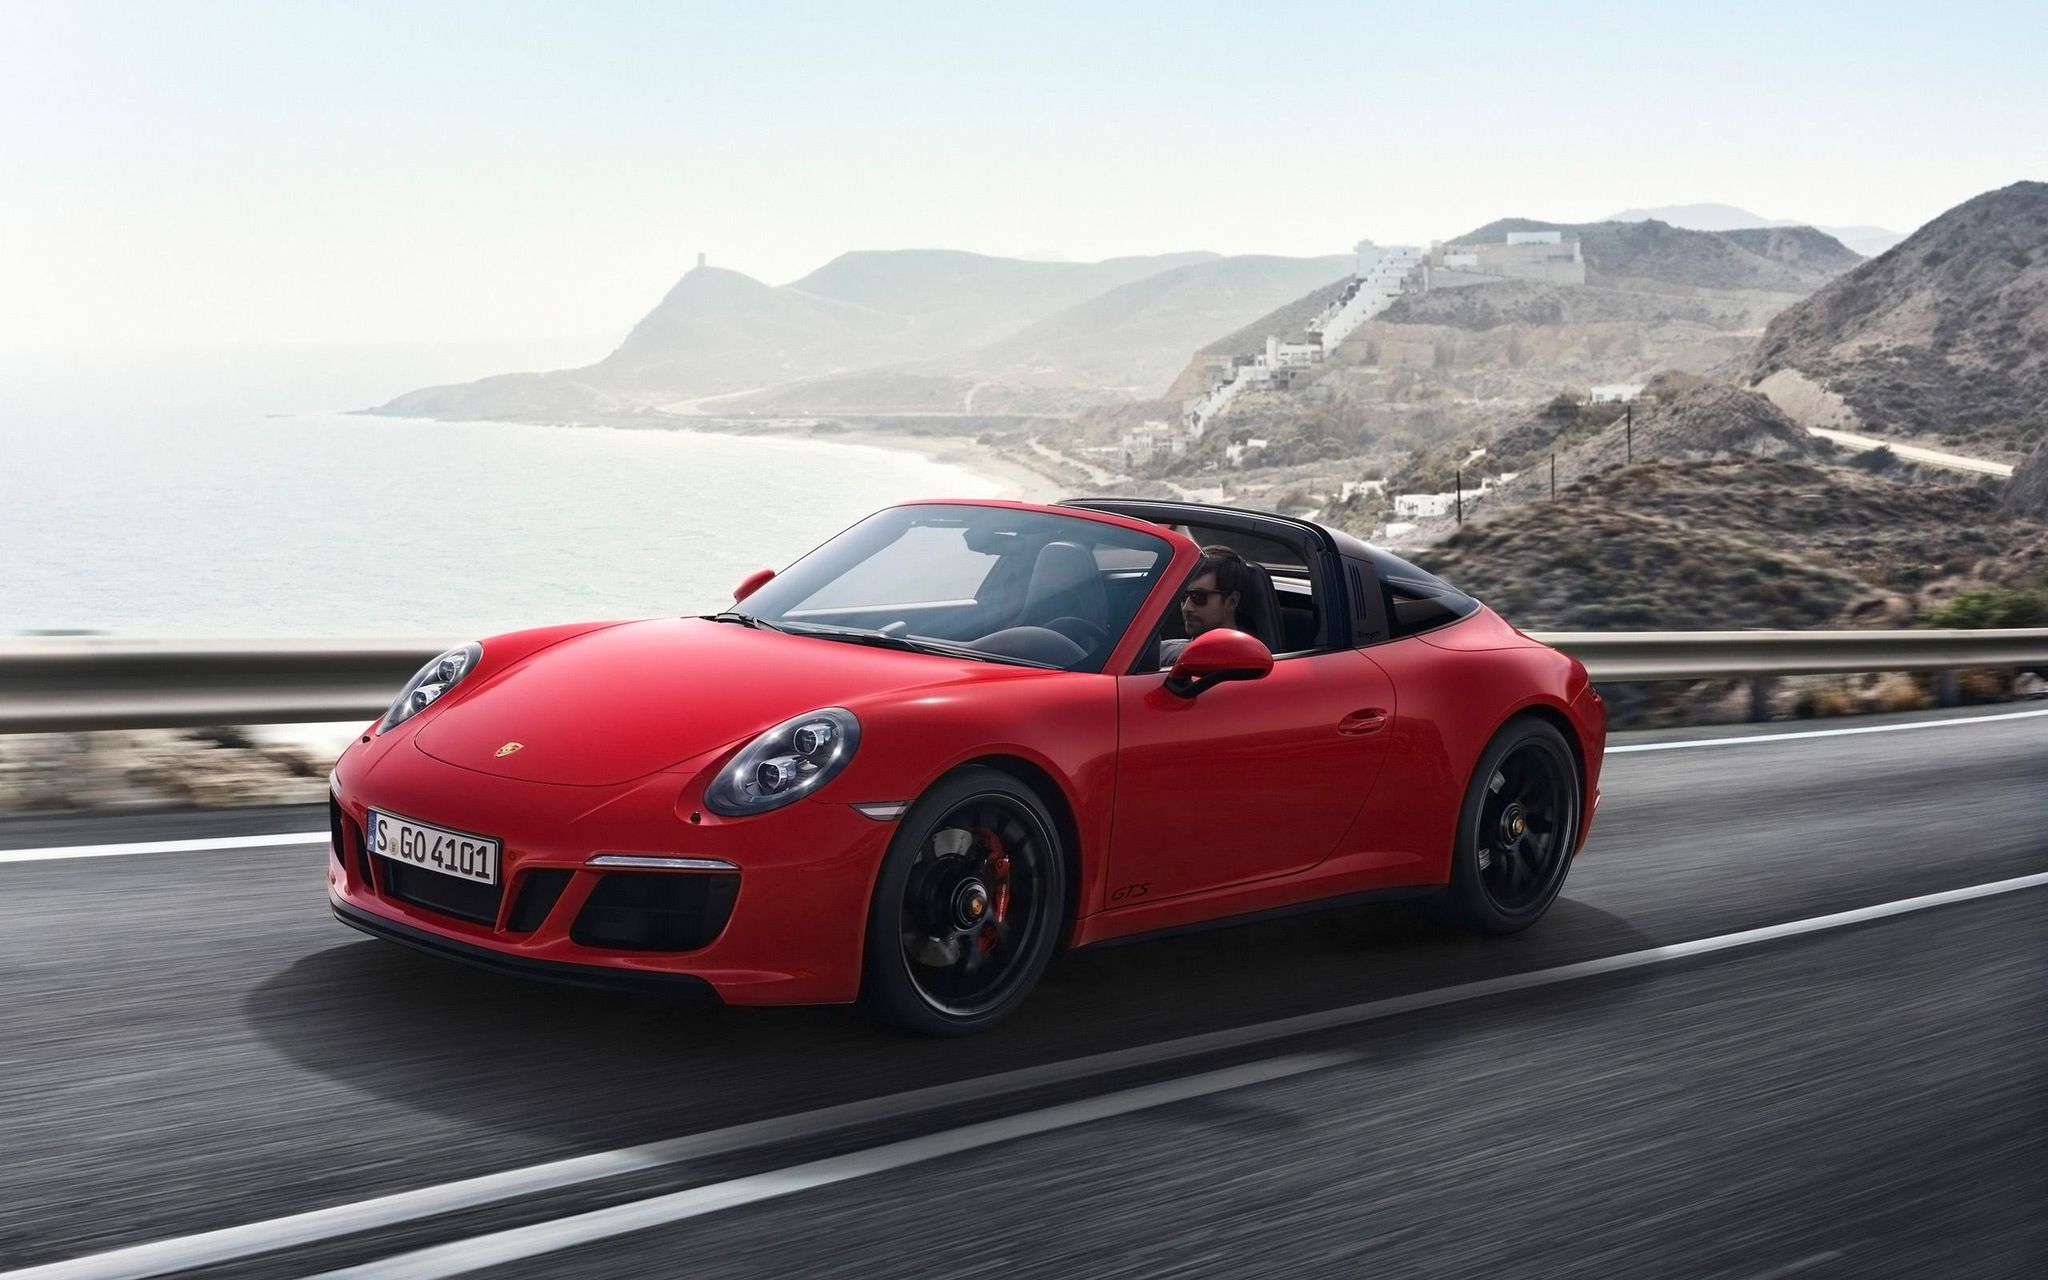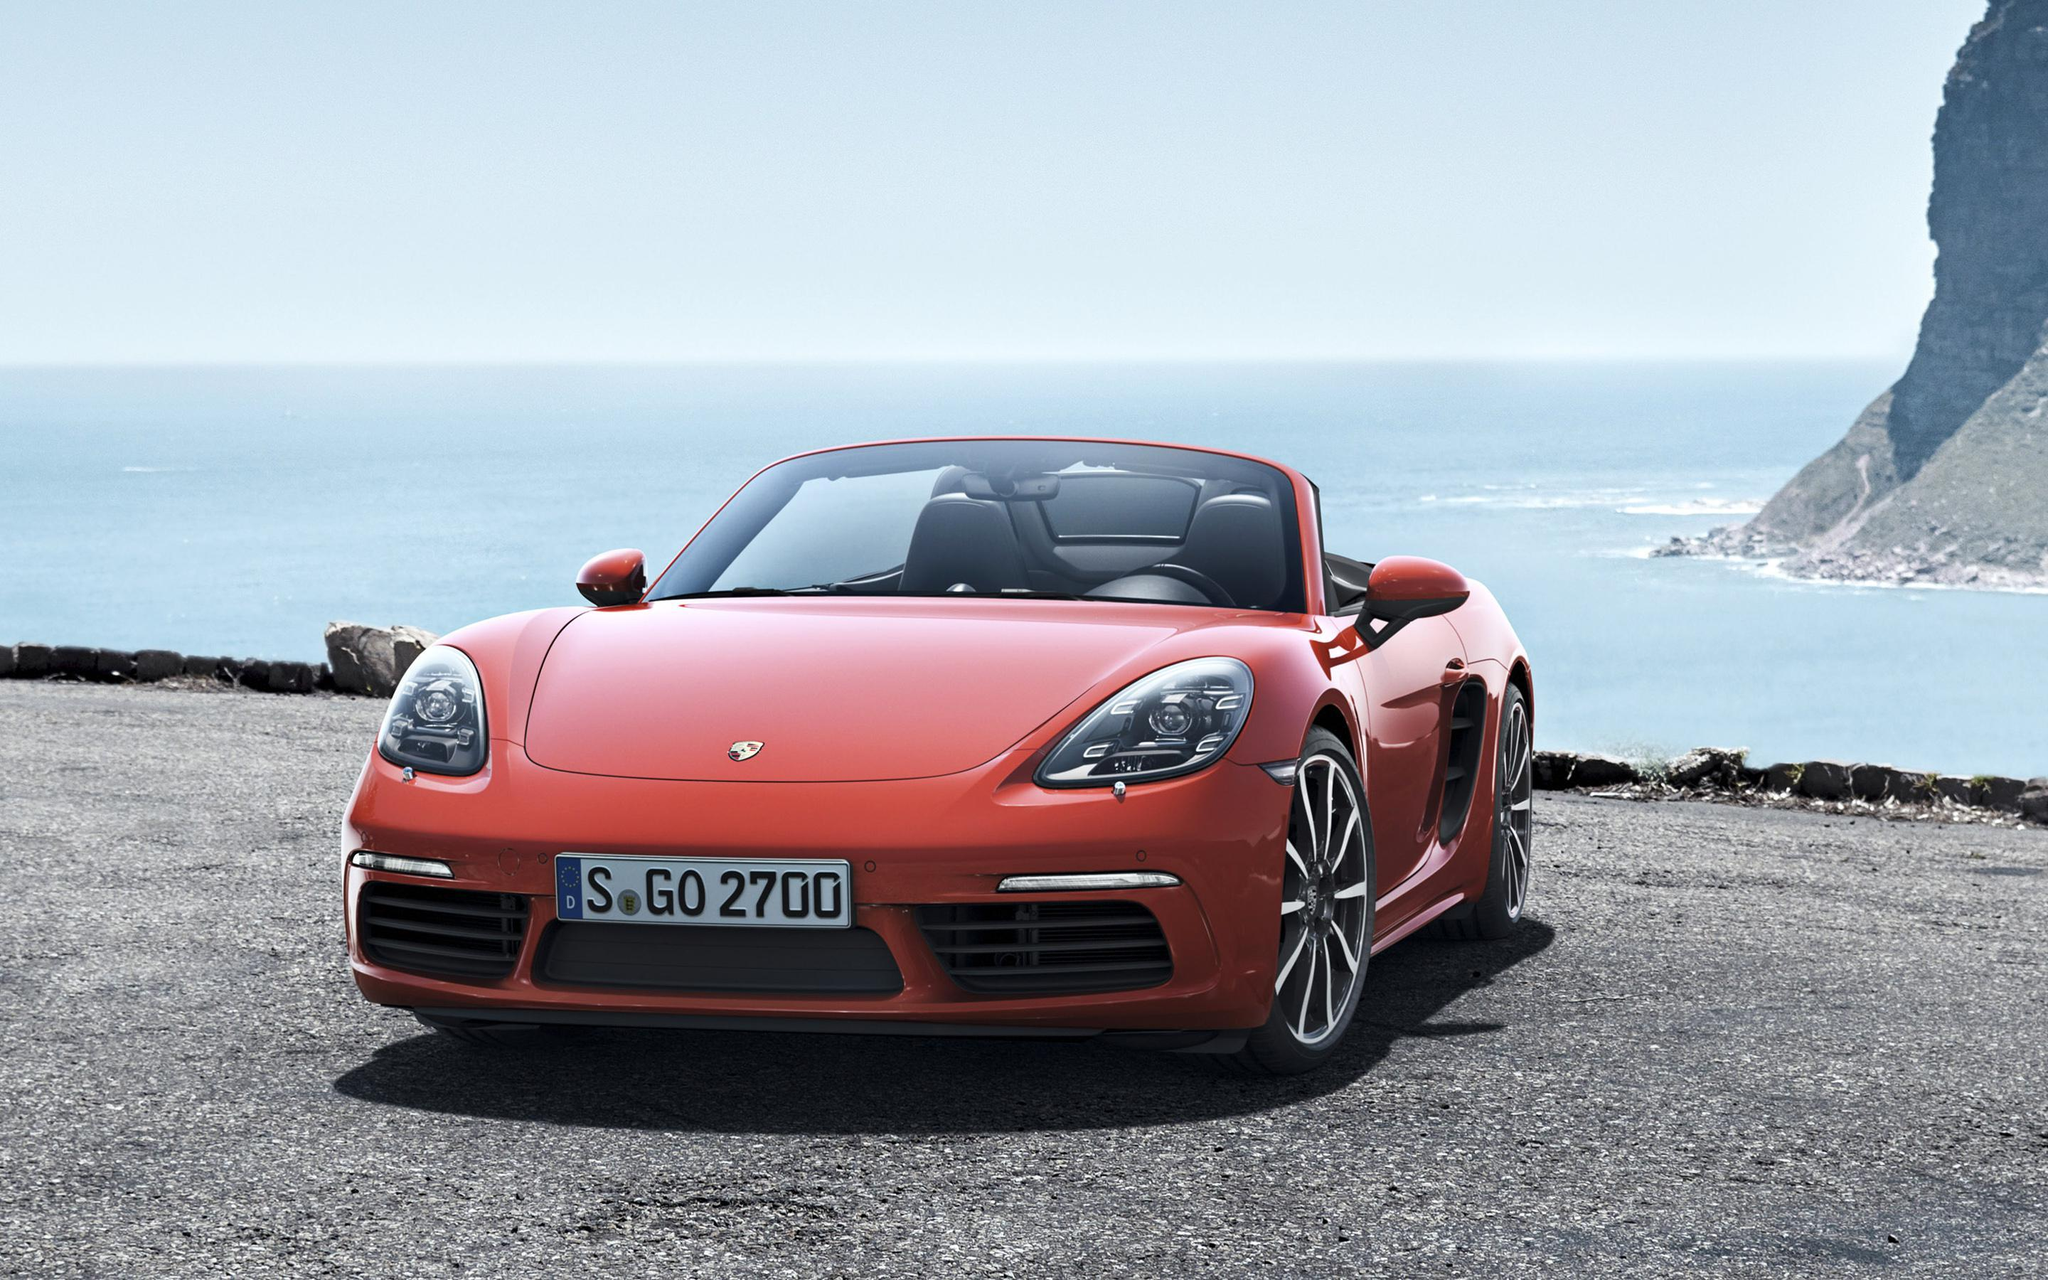The first image is the image on the left, the second image is the image on the right. Evaluate the accuracy of this statement regarding the images: "The right image has a convertible with the ocean visible behind it". Is it true? Answer yes or no. Yes. The first image is the image on the left, the second image is the image on the right. Evaluate the accuracy of this statement regarding the images: "Both cars are red.". Is it true? Answer yes or no. Yes. 